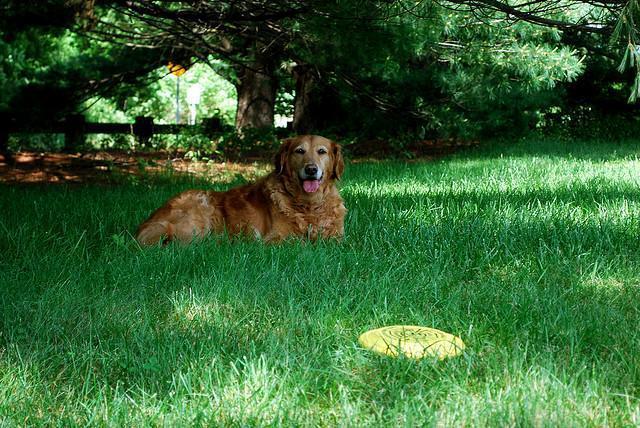How many people are wearing blue shirts?
Give a very brief answer. 0. 